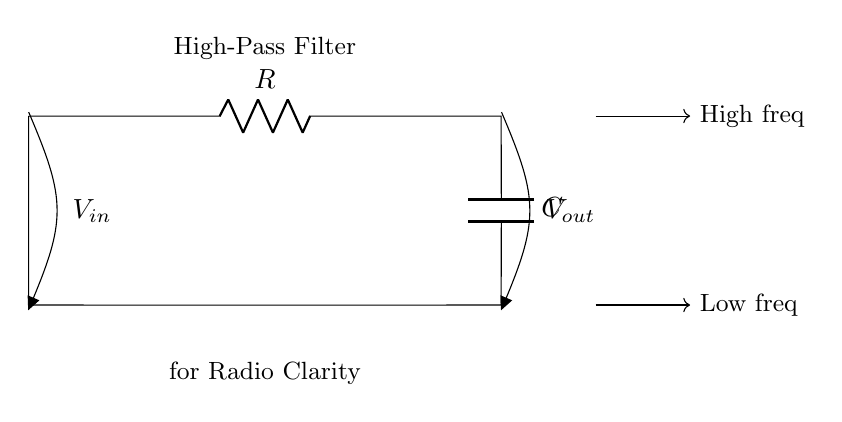What components are in this circuit? The circuit contains a resistor and a capacitor, which are designated as R and C respectively in the diagram.
Answer: Resistor and Capacitor What is the purpose of this circuit? This circuit acts as a high-pass filter, which helps improve the clarity of radio announcements by allowing high-frequency signals to pass while attenuating low-frequency signals.
Answer: High-pass filter What does V in represent? V in represents the input voltage, which is the voltage applied to the circuit at the input terminal.
Answer: Input voltage What does V out represent? V out represents the output voltage, which is the voltage taken from the output terminal after the high-pass filtering effect.
Answer: Output voltage What happens to low frequencies in this circuit? Low frequencies are attenuated in a high-pass filter, which means they are reduced in amplitude at the output compared to the input.
Answer: Attenuated How does the capacitor affect the signal? The capacitor blocks low-frequency signals and allows high-frequency signals to pass through, thus shaping the signal output for clarity.
Answer: Blocks low frequencies What is the frequency behavior of this circuit? The circuit allows high frequencies to be transmitted and blocks low frequencies, distinguishing it as a high-pass filter.
Answer: Allows high frequencies 